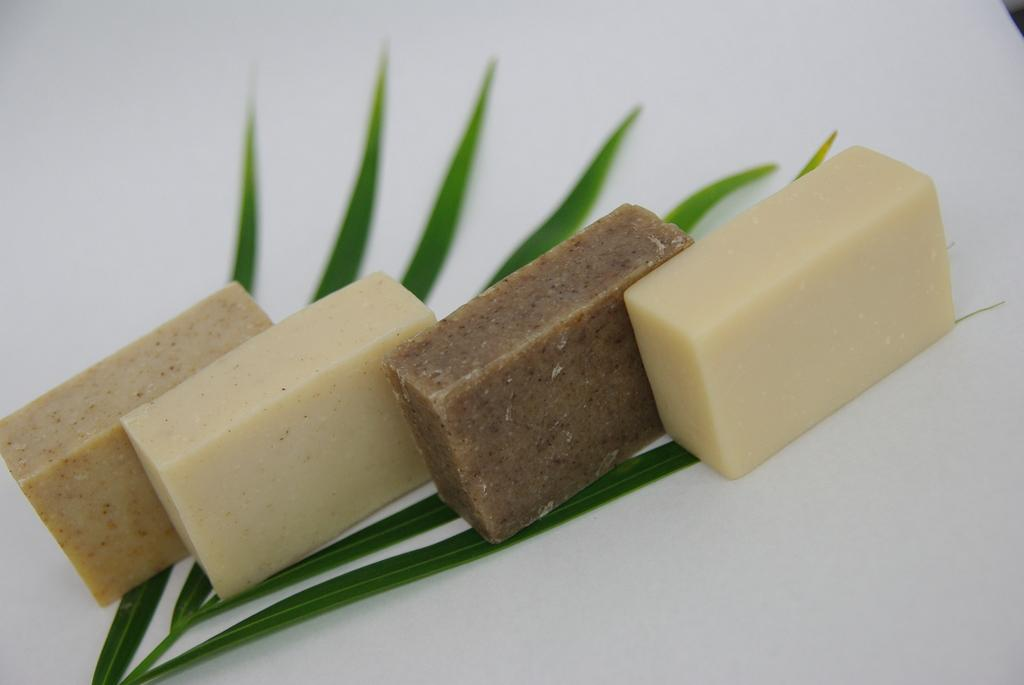What types of items can be seen in the image? There are food items and a leaf in the image. What is the color of the surface in the image? The surface in the image is white-colored. What type of gun is visible on the desk in the image? There is no gun or desk present in the image; it only contains food items and a leaf on a white surface. 